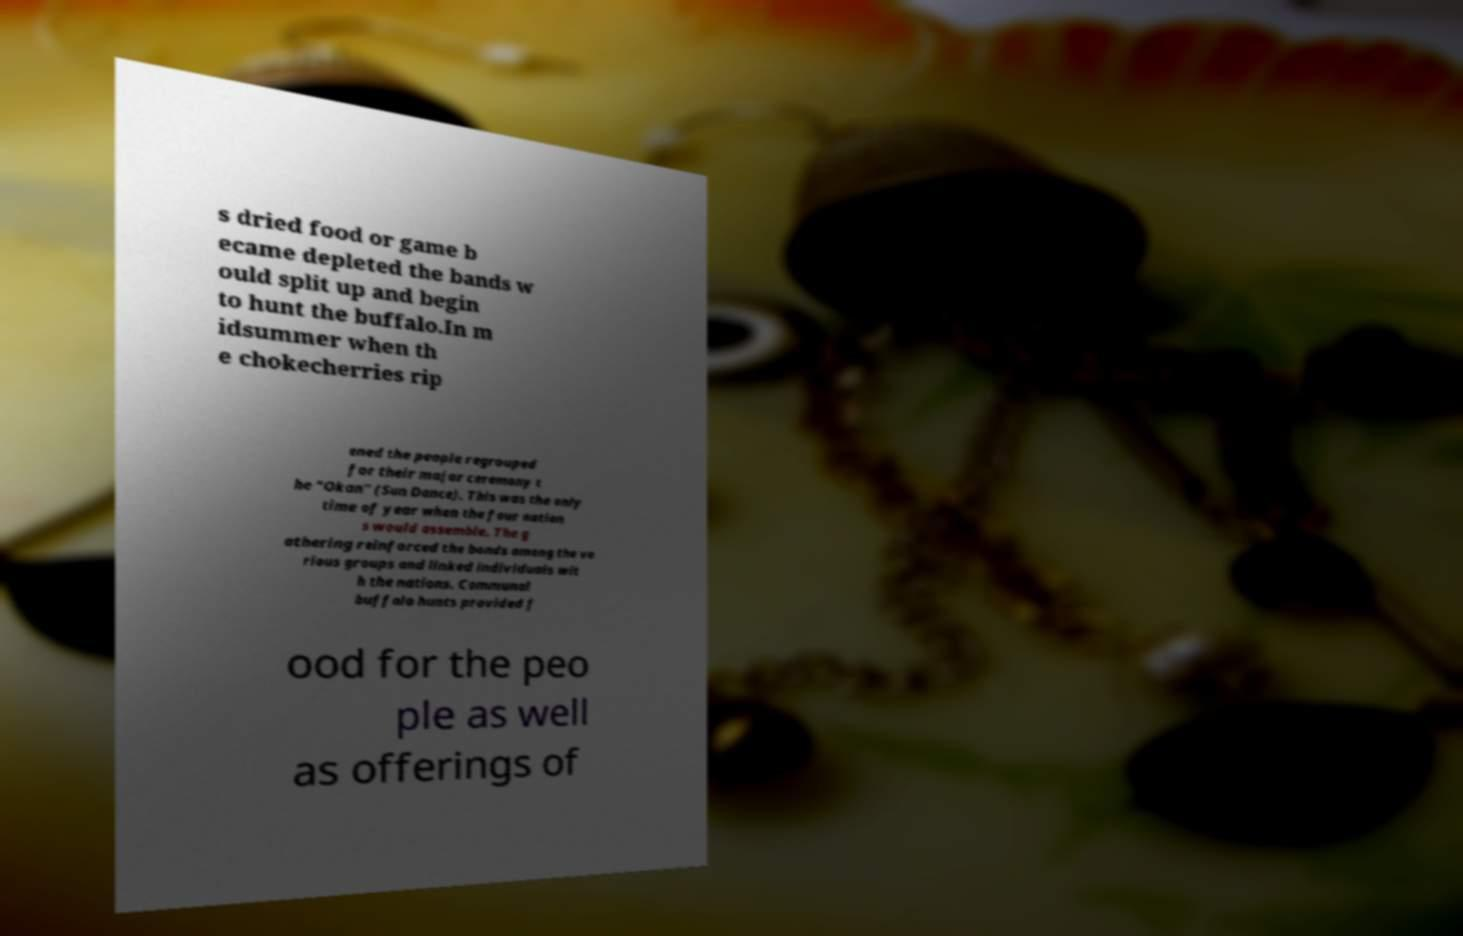Could you assist in decoding the text presented in this image and type it out clearly? s dried food or game b ecame depleted the bands w ould split up and begin to hunt the buffalo.In m idsummer when th e chokecherries rip ened the people regrouped for their major ceremony t he "Okan" (Sun Dance). This was the only time of year when the four nation s would assemble. The g athering reinforced the bonds among the va rious groups and linked individuals wit h the nations. Communal buffalo hunts provided f ood for the peo ple as well as offerings of 